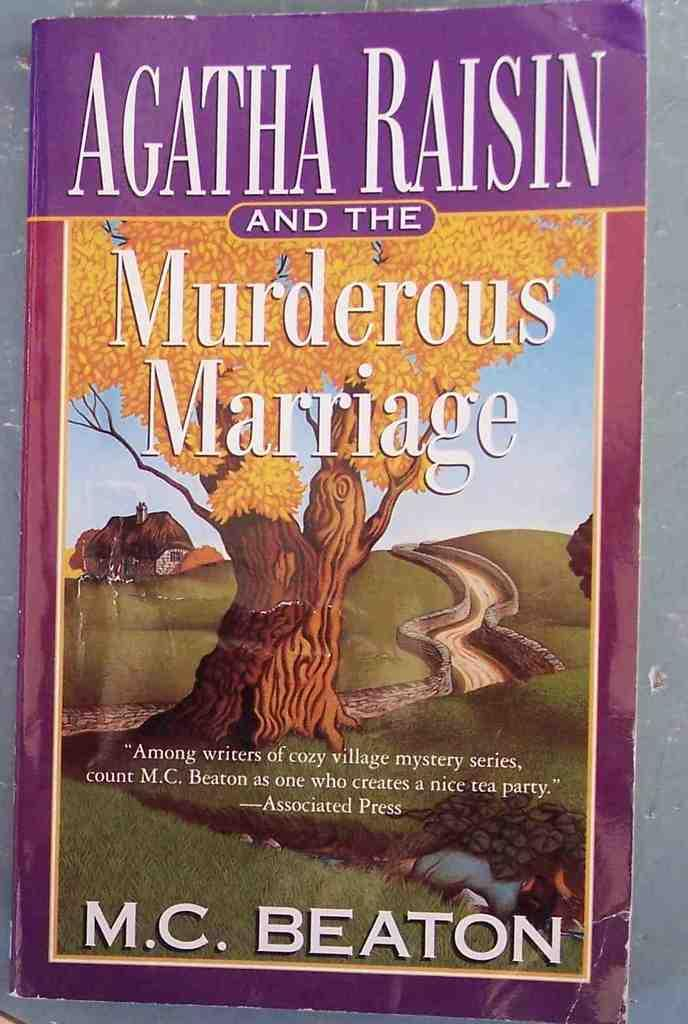What object is present in the picture? There is a book in the picture. What can be seen on the book cover? The book cover has text on it, images of a tree, and images of houses. What type of donkey can be seen playing in the dust during the summer in the image? There is no donkey or dust present in the image, and the image does not depict a summer scene. 